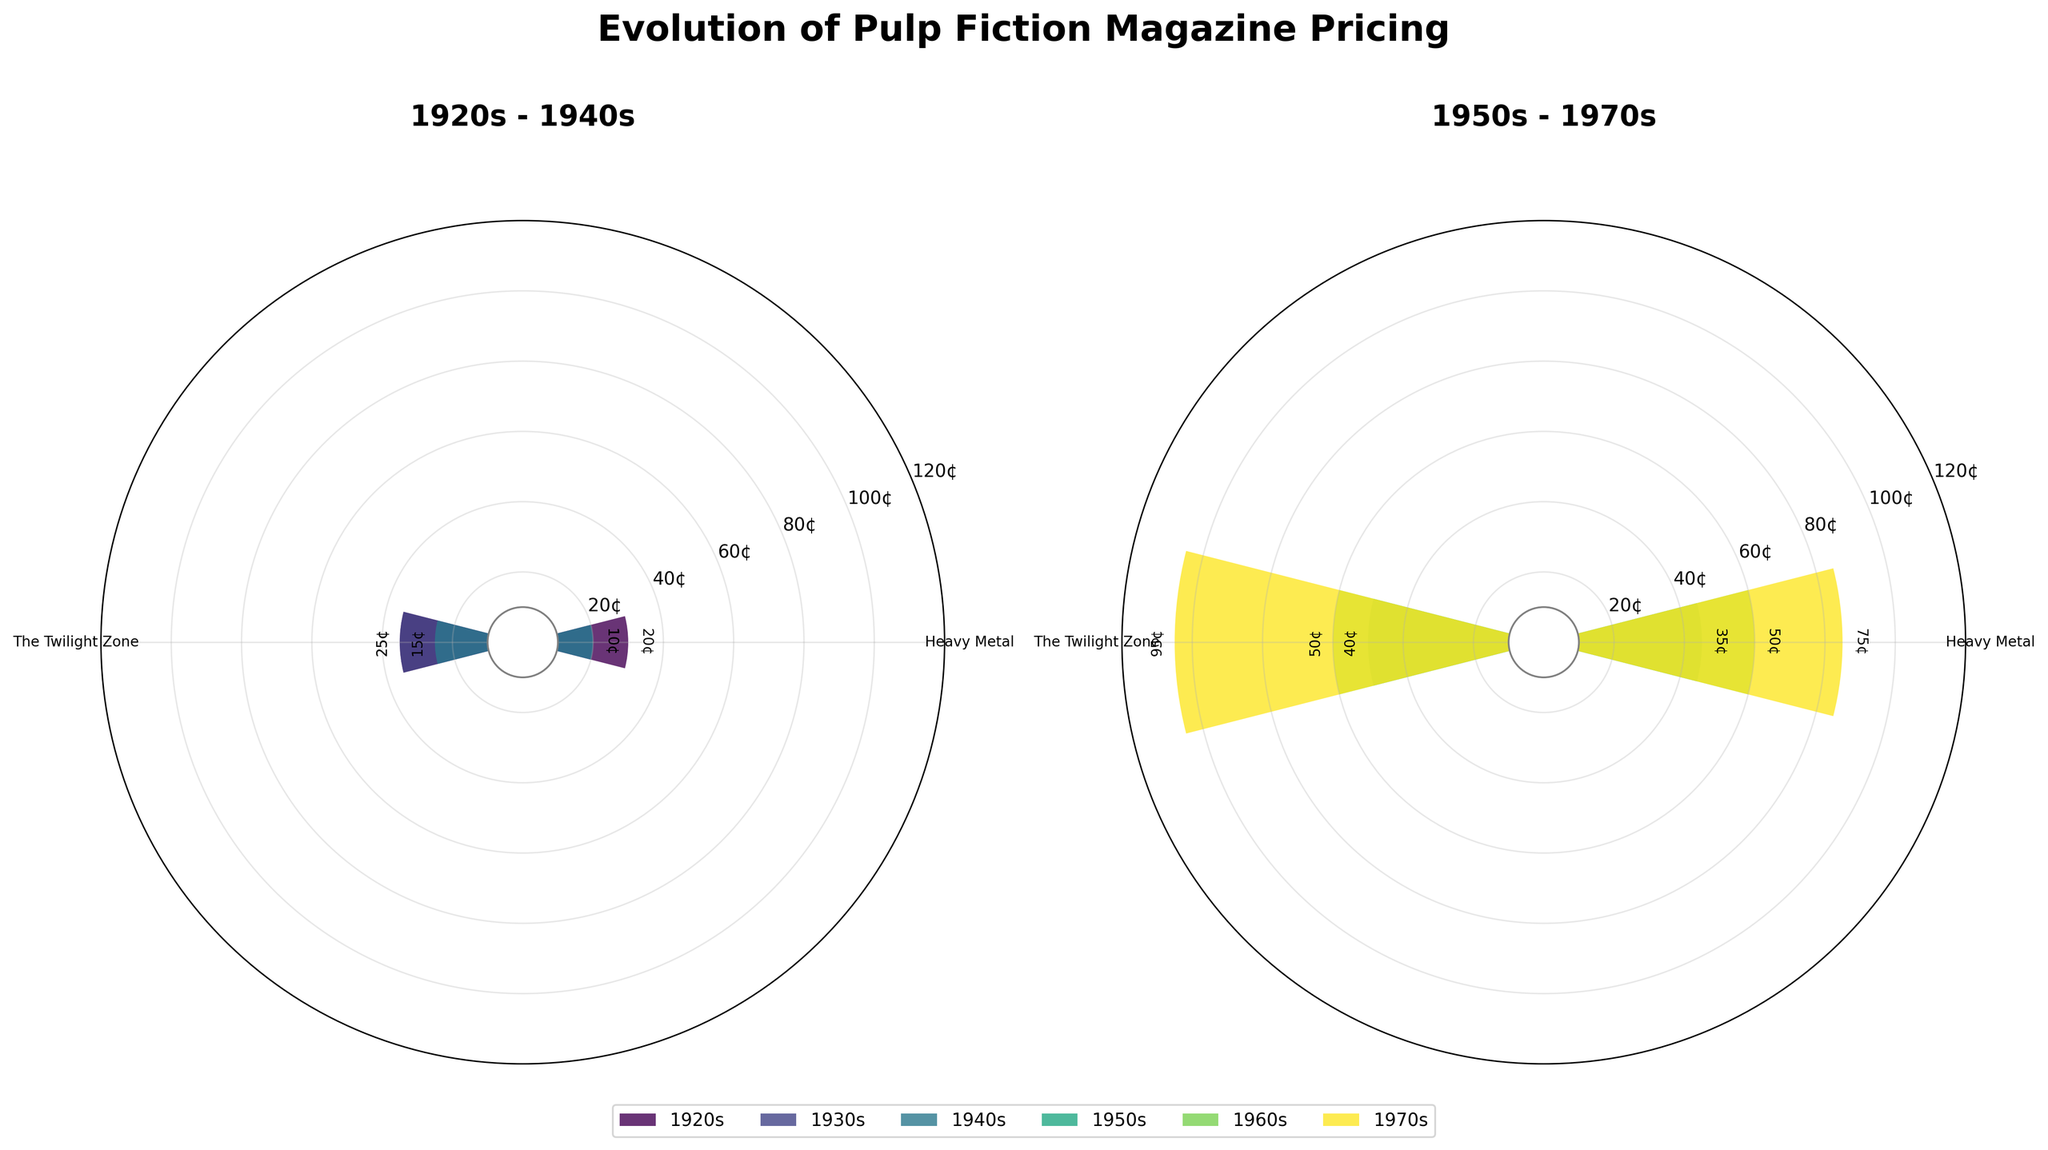What is the title of the figure? The title is written at the top of the figure.
Answer: Evolution of Pulp Fiction Magazine Pricing How many decades are represented in the figure? The figure is divided into two subplots, each labeled with specific decades.
Answer: 6 What is the highest price of a magazine in the 1970s? The prices are shown on the bar labels in the subplot for the 1970s.
Answer: 95 cents Which decade had the lowest magazine price? By comparing the prices in each decade, the 1930s and 1940s feature the lowest price. However, the 1930s appears first when considering these equally.
Answer: 1930s Which magazine had a price of 40 cents? By looking at the bar labels, you can find "40¢" on the subplot mentioning 1950s to 1970s.
Answer: Famous Monsters of Filmland What is the price difference between the most expensive magazines in the 1920s and 1960s? Identify the highest prices in both the 1920s and the 1960s and subtract them. The highest price is 25 cents in the 1920s and 50 cents in the 1960s.
Answer: 25 cents Which decade shows the most significant increase in prices compared to the previous decade? Compare the price increases from each decade to the next and identify the one with the most substantial rise.
Answer: 1970s How does the number of magazines in the 1930s compare to the number of magazines in the 1950s? Count the number of bars or labels for each decade to find the quantities.
Answer: The 1930s have 2 magazines, and the 1950s have 2 magazines On which plot would you find the magazine "Analog Science Fiction"? Identify the subplot titles; "Analog Science Fiction" belongs to the "1950s - 1970s" period.
Answer: 1950s - 1970s What is the price range for magazines in the 1940s? Identify the lowest and highest prices in the subplot for the 1940s. The lowest price is 10 cents, and the highest is 15 cents.
Answer: 10 to 15 cents 